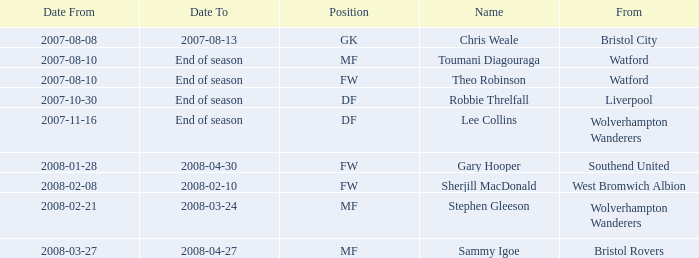From what place was the player with the df position who commenced on october 30, 2007? Liverpool. 